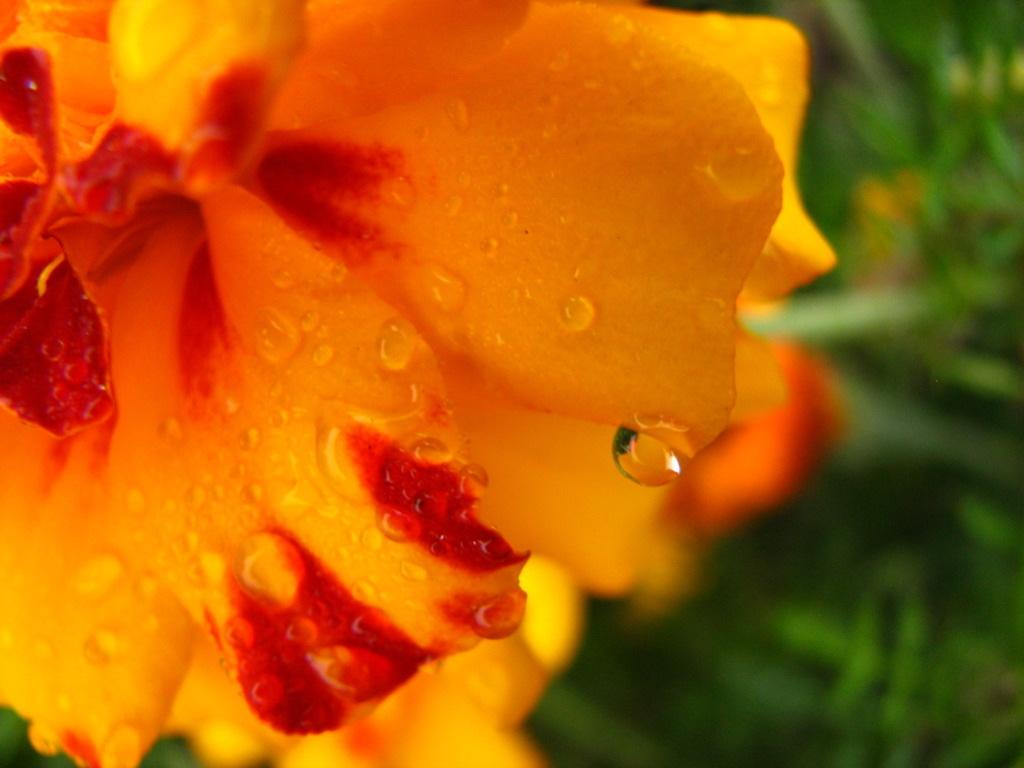What is the main subject of the image? There is a flower in the image. Can you describe the background of the image? The background of the image is blurred. How many planes are flying in the background of the image? There are no planes visible in the image; the background is blurred and only features the flower. What type of government is depicted in the image? There is no government depicted in the image; it features a flower and a blurred background. 